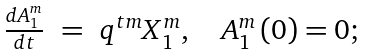<formula> <loc_0><loc_0><loc_500><loc_500>\begin{array} { l l l } \frac { d A _ { 1 } ^ { m } } { d t } & = & q ^ { t m } X _ { 1 } ^ { m } , \quad A _ { 1 } ^ { m } \left ( 0 \right ) = 0 ; \end{array}</formula> 